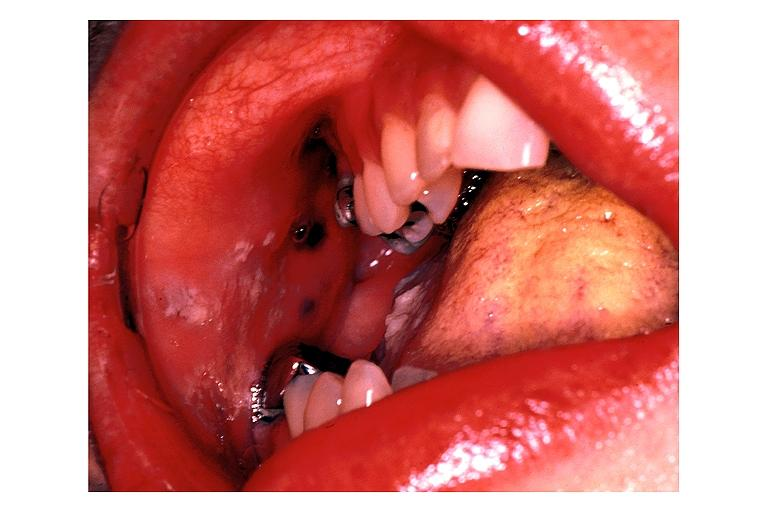s oral present?
Answer the question using a single word or phrase. Yes 